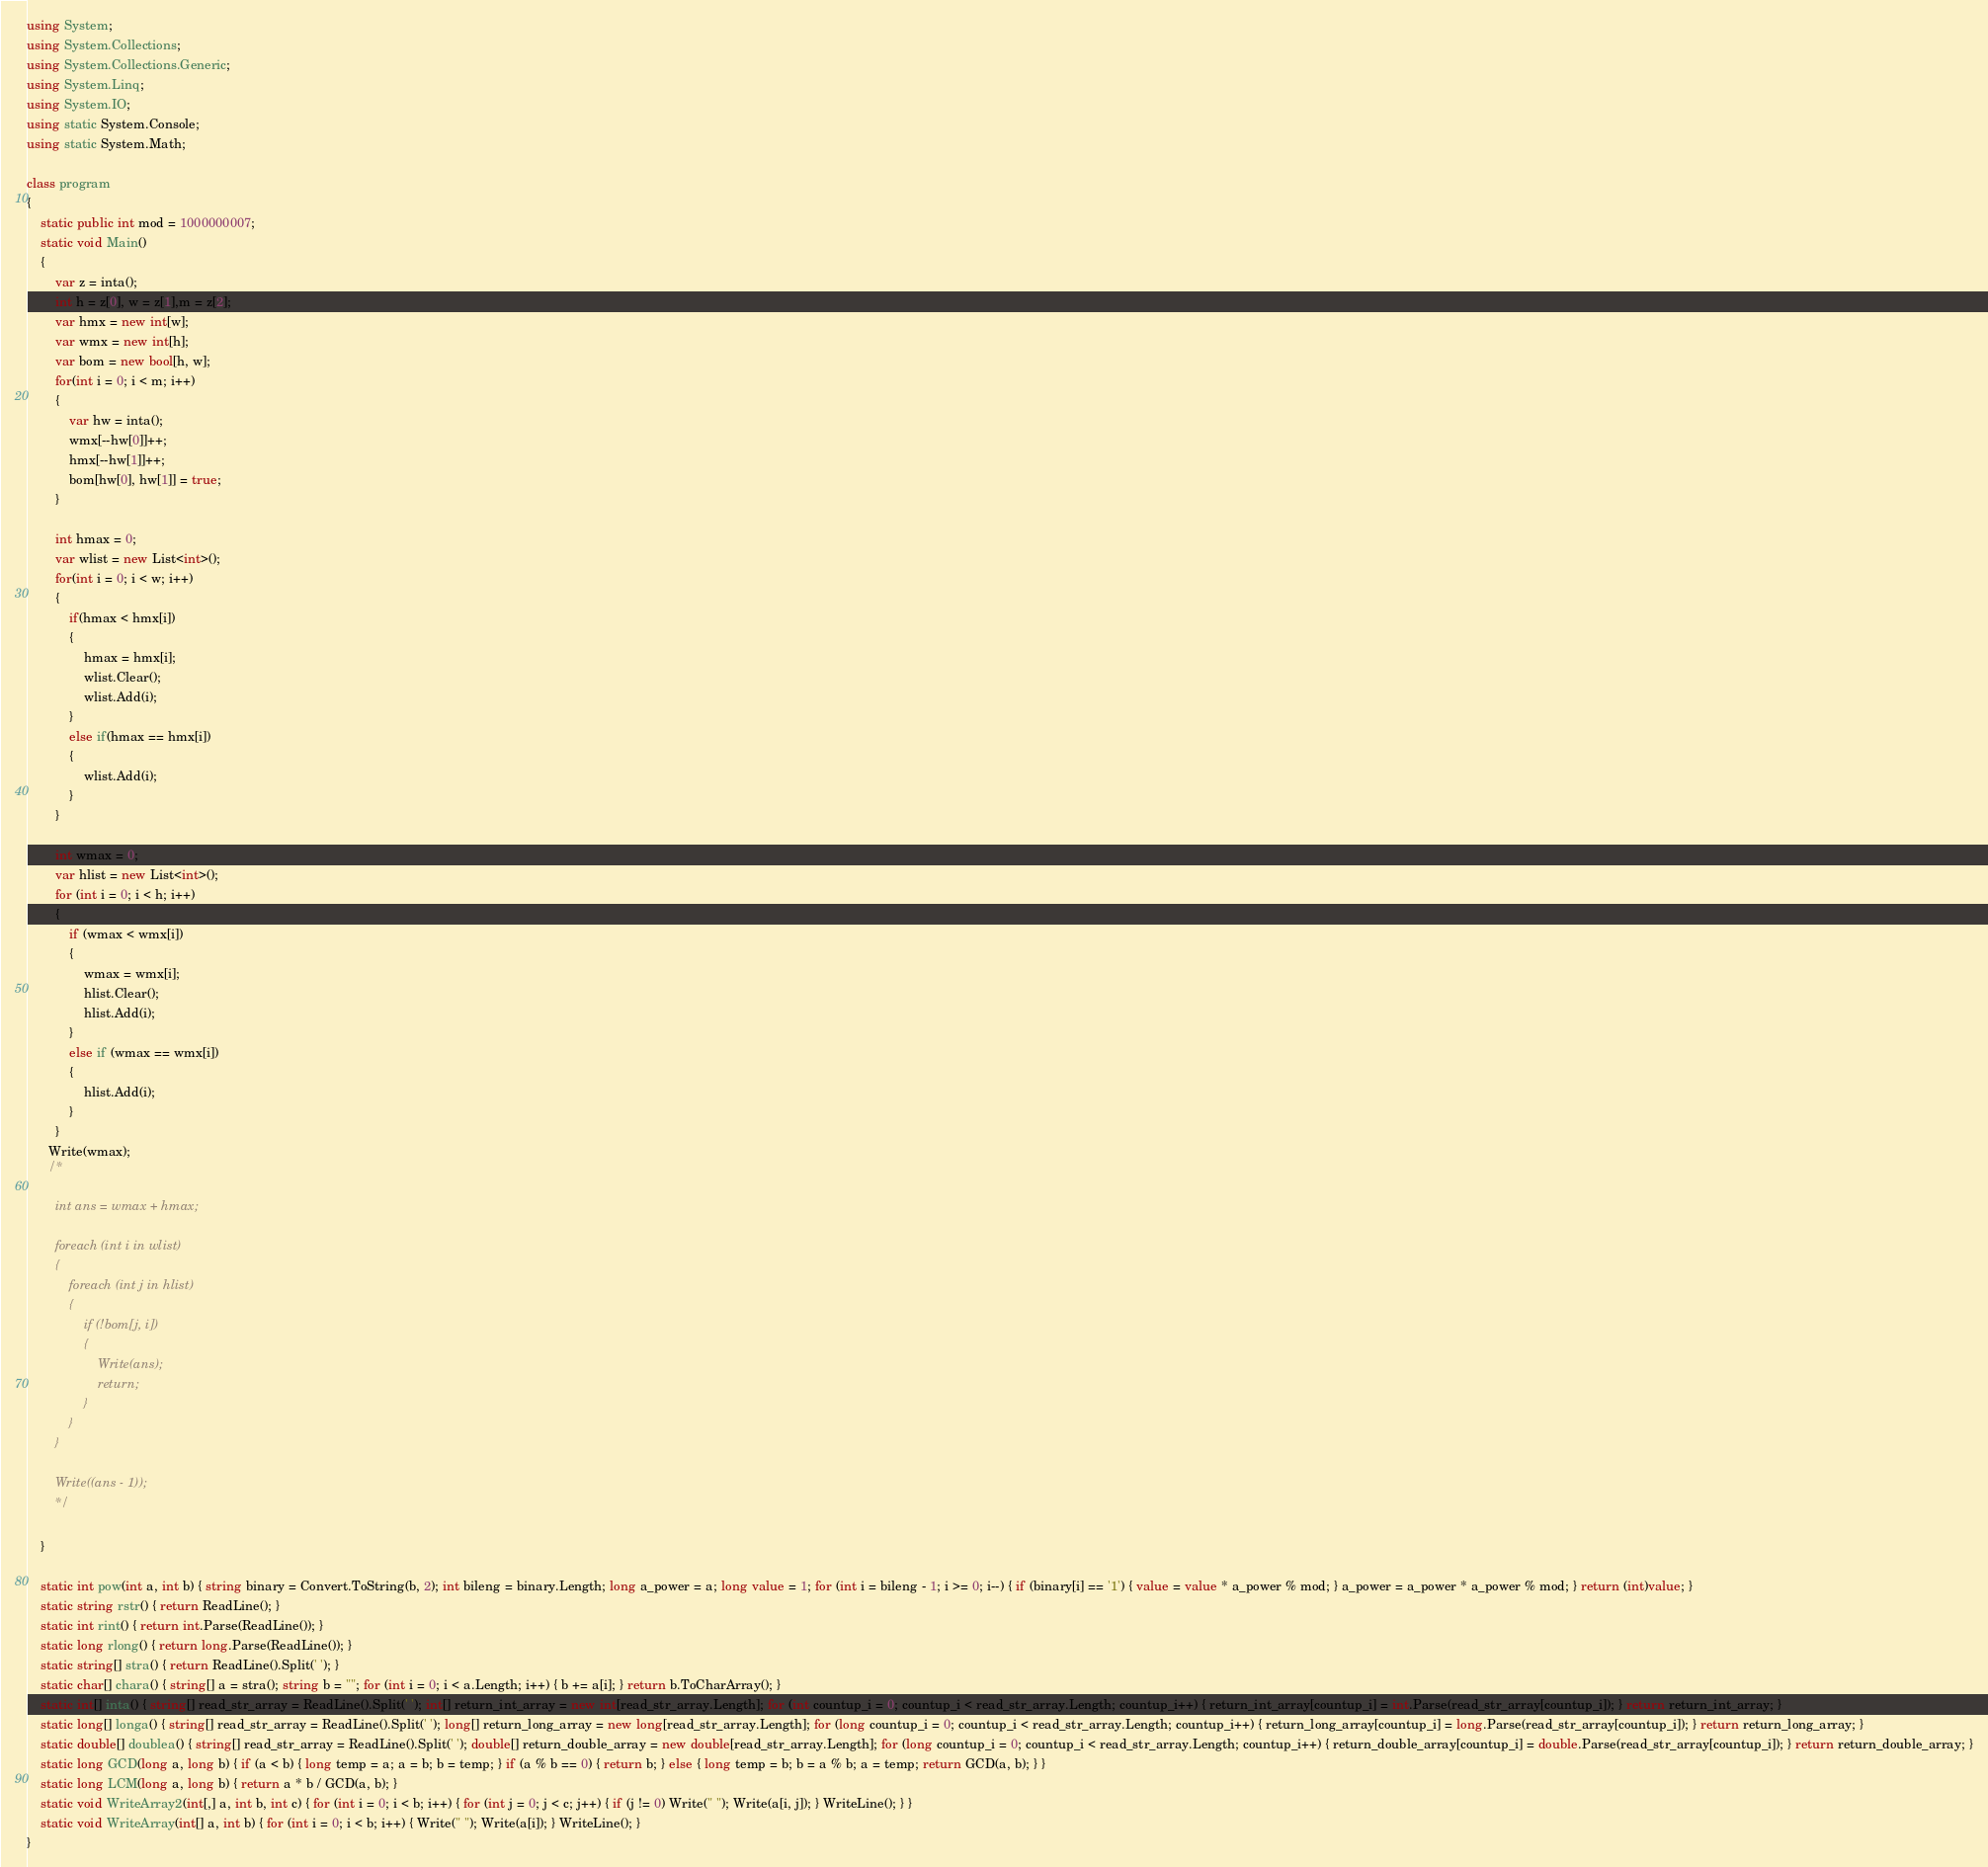Convert code to text. <code><loc_0><loc_0><loc_500><loc_500><_C#_>using System;
using System.Collections;
using System.Collections.Generic;
using System.Linq;
using System.IO;
using static System.Console;
using static System.Math;

class program
{
    static public int mod = 1000000007;
    static void Main()
    {
        var z = inta();
        int h = z[0], w = z[1],m = z[2];
        var hmx = new int[w];
        var wmx = new int[h];
        var bom = new bool[h, w];
        for(int i = 0; i < m; i++)
        {
            var hw = inta();
            wmx[--hw[0]]++;
            hmx[--hw[1]]++;
            bom[hw[0], hw[1]] = true;
        }

        int hmax = 0;
        var wlist = new List<int>();
        for(int i = 0; i < w; i++)
        {
            if(hmax < hmx[i])
            {
                hmax = hmx[i];
                wlist.Clear();
                wlist.Add(i);
            }
            else if(hmax == hmx[i])
            {
                wlist.Add(i);
            }
        }

        int wmax = 0;
        var hlist = new List<int>();
        for (int i = 0; i < h; i++)
        {
            if (wmax < wmx[i])
            {
                wmax = wmx[i];
                hlist.Clear();
                hlist.Add(i);
            }
            else if (wmax == wmx[i])
            {
                hlist.Add(i);
            }
        }
      Write(wmax);
      /*

        int ans = wmax + hmax;

        foreach (int i in wlist)
        {
            foreach (int j in hlist)
            {
                if (!bom[j, i])
                {
                    Write(ans);
                    return;
                }
            }
        }

        Write((ans - 1));
        */
 
    }

    static int pow(int a, int b) { string binary = Convert.ToString(b, 2); int bileng = binary.Length; long a_power = a; long value = 1; for (int i = bileng - 1; i >= 0; i--) { if (binary[i] == '1') { value = value * a_power % mod; } a_power = a_power * a_power % mod; } return (int)value; }
    static string rstr() { return ReadLine(); }
    static int rint() { return int.Parse(ReadLine()); }
    static long rlong() { return long.Parse(ReadLine()); }
    static string[] stra() { return ReadLine().Split(' '); }
    static char[] chara() { string[] a = stra(); string b = ""; for (int i = 0; i < a.Length; i++) { b += a[i]; } return b.ToCharArray(); }
    static int[] inta() { string[] read_str_array = ReadLine().Split(' '); int[] return_int_array = new int[read_str_array.Length]; for (int countup_i = 0; countup_i < read_str_array.Length; countup_i++) { return_int_array[countup_i] = int.Parse(read_str_array[countup_i]); } return return_int_array; }
    static long[] longa() { string[] read_str_array = ReadLine().Split(' '); long[] return_long_array = new long[read_str_array.Length]; for (long countup_i = 0; countup_i < read_str_array.Length; countup_i++) { return_long_array[countup_i] = long.Parse(read_str_array[countup_i]); } return return_long_array; }
    static double[] doublea() { string[] read_str_array = ReadLine().Split(' '); double[] return_double_array = new double[read_str_array.Length]; for (long countup_i = 0; countup_i < read_str_array.Length; countup_i++) { return_double_array[countup_i] = double.Parse(read_str_array[countup_i]); } return return_double_array; }
    static long GCD(long a, long b) { if (a < b) { long temp = a; a = b; b = temp; } if (a % b == 0) { return b; } else { long temp = b; b = a % b; a = temp; return GCD(a, b); } }
    static long LCM(long a, long b) { return a * b / GCD(a, b); }
    static void WriteArray2(int[,] a, int b, int c) { for (int i = 0; i < b; i++) { for (int j = 0; j < c; j++) { if (j != 0) Write(" "); Write(a[i, j]); } WriteLine(); } }
    static void WriteArray(int[] a, int b) { for (int i = 0; i < b; i++) { Write(" "); Write(a[i]); } WriteLine(); }
}
</code> 